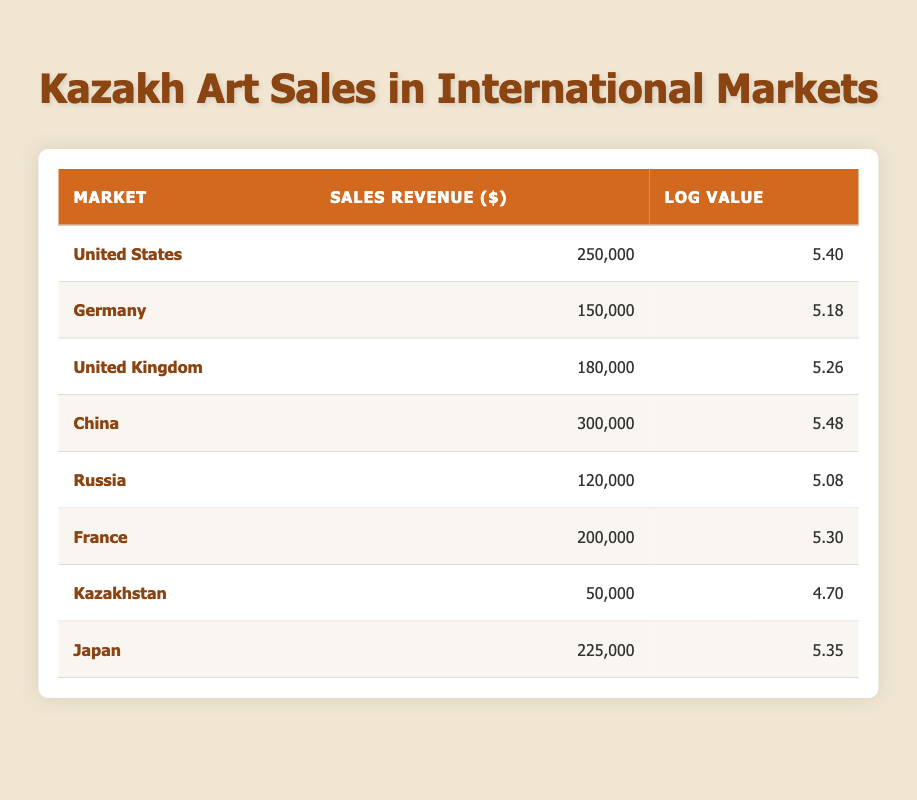What is the sales revenue of Kazakh artworks in China? The sales revenue for Kazakh artworks in China is provided directly in the table under the "Sales Revenue" column, which states it as 300,000.
Answer: 300,000 Which country has the lowest sales revenue for Kazakh artworks? Looking through the "Sales Revenue" column, the entry for Kazakhstan shows the lowest value of 50,000 compared to other markets.
Answer: Kazakhstan What is the average sales revenue across all markets listed? To find the average, we sum the sales revenues: (250,000 + 150,000 + 180,000 + 300,000 + 120,000 + 200,000 + 50,000 + 225,000) = 1,475,000. Dividing this sum by the number of markets (8) gives us an average of 1,475,000 / 8 = 184,375.
Answer: 184,375 Is the sales revenue of Kazakh artworks in the United States greater than that in Japan? The sales revenue for the United States is 250,000 and for Japan it is 225,000. Since 250,000 is greater than 225,000, the statement is true.
Answer: Yes What is the difference in sales revenue between the highest and the lowest markets? The highest sales revenue is in China at 300,000, and the lowest is in Kazakhstan at 50,000. To find the difference, we subtract the lowest from the highest: 300,000 - 50,000 = 250,000.
Answer: 250,000 How many countries have sales revenues that exceed 200,000? By examining the sales revenues, we find that China (300,000), United States (250,000), and France (200,000) have revenues that exceed 200,000. This gives us a total of 3 countries.
Answer: 3 Is it true that the log value for sales revenue in Germany is greater than that in Russia? The log value for Germany is 5.18 and for Russia it is 5.08. Since 5.18 is greater than 5.08, the statement is true.
Answer: Yes What is the total sales revenue for markets located in Europe? The European markets are Germany, United Kingdom, France, and Russia. Their sales revenues are 150,000, 180,000, 200,000, and 120,000 respectively. Adding these together gives us: 150,000 + 180,000 + 200,000 + 120,000 = 650,000.
Answer: 650,000 